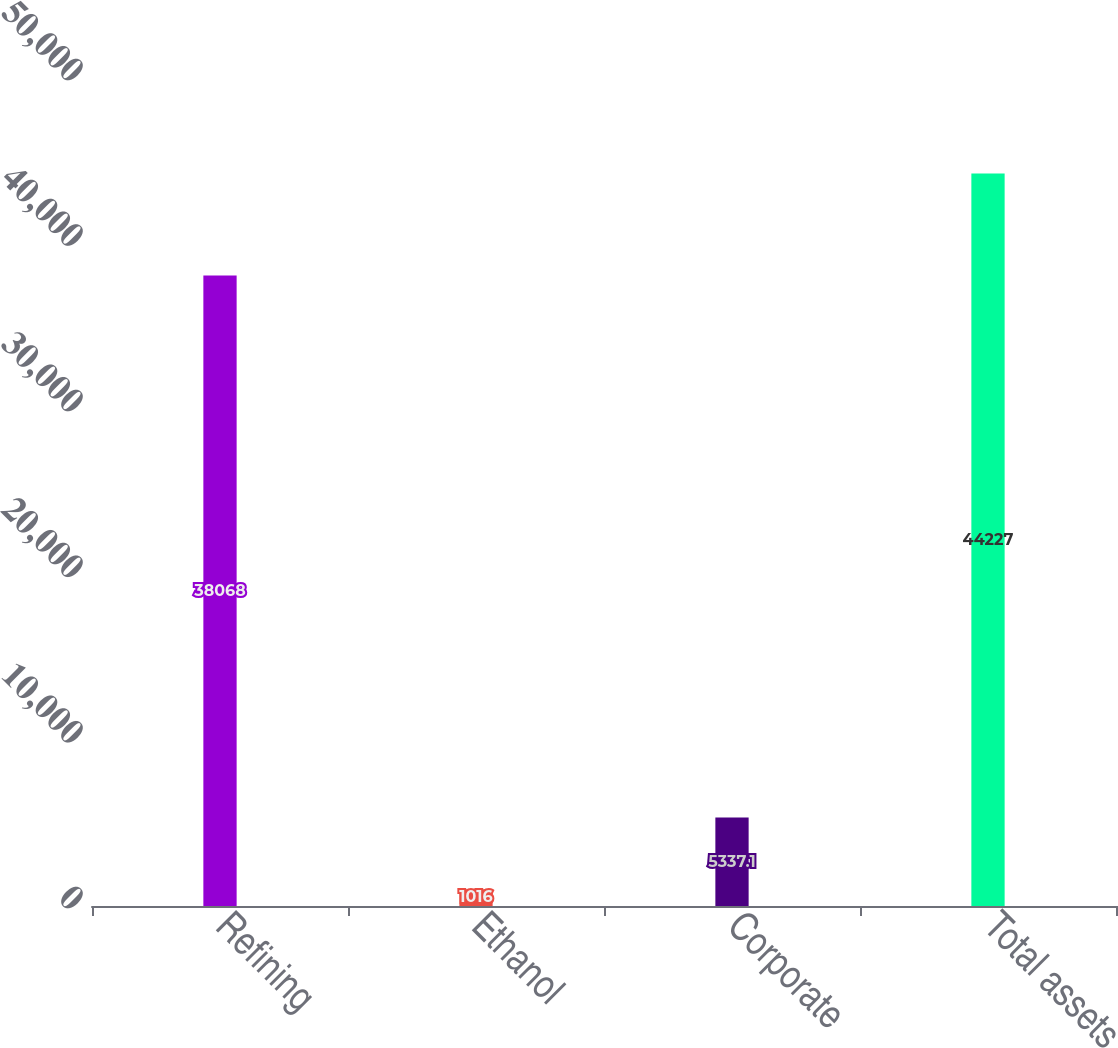<chart> <loc_0><loc_0><loc_500><loc_500><bar_chart><fcel>Refining<fcel>Ethanol<fcel>Corporate<fcel>Total assets<nl><fcel>38068<fcel>1016<fcel>5337.1<fcel>44227<nl></chart> 